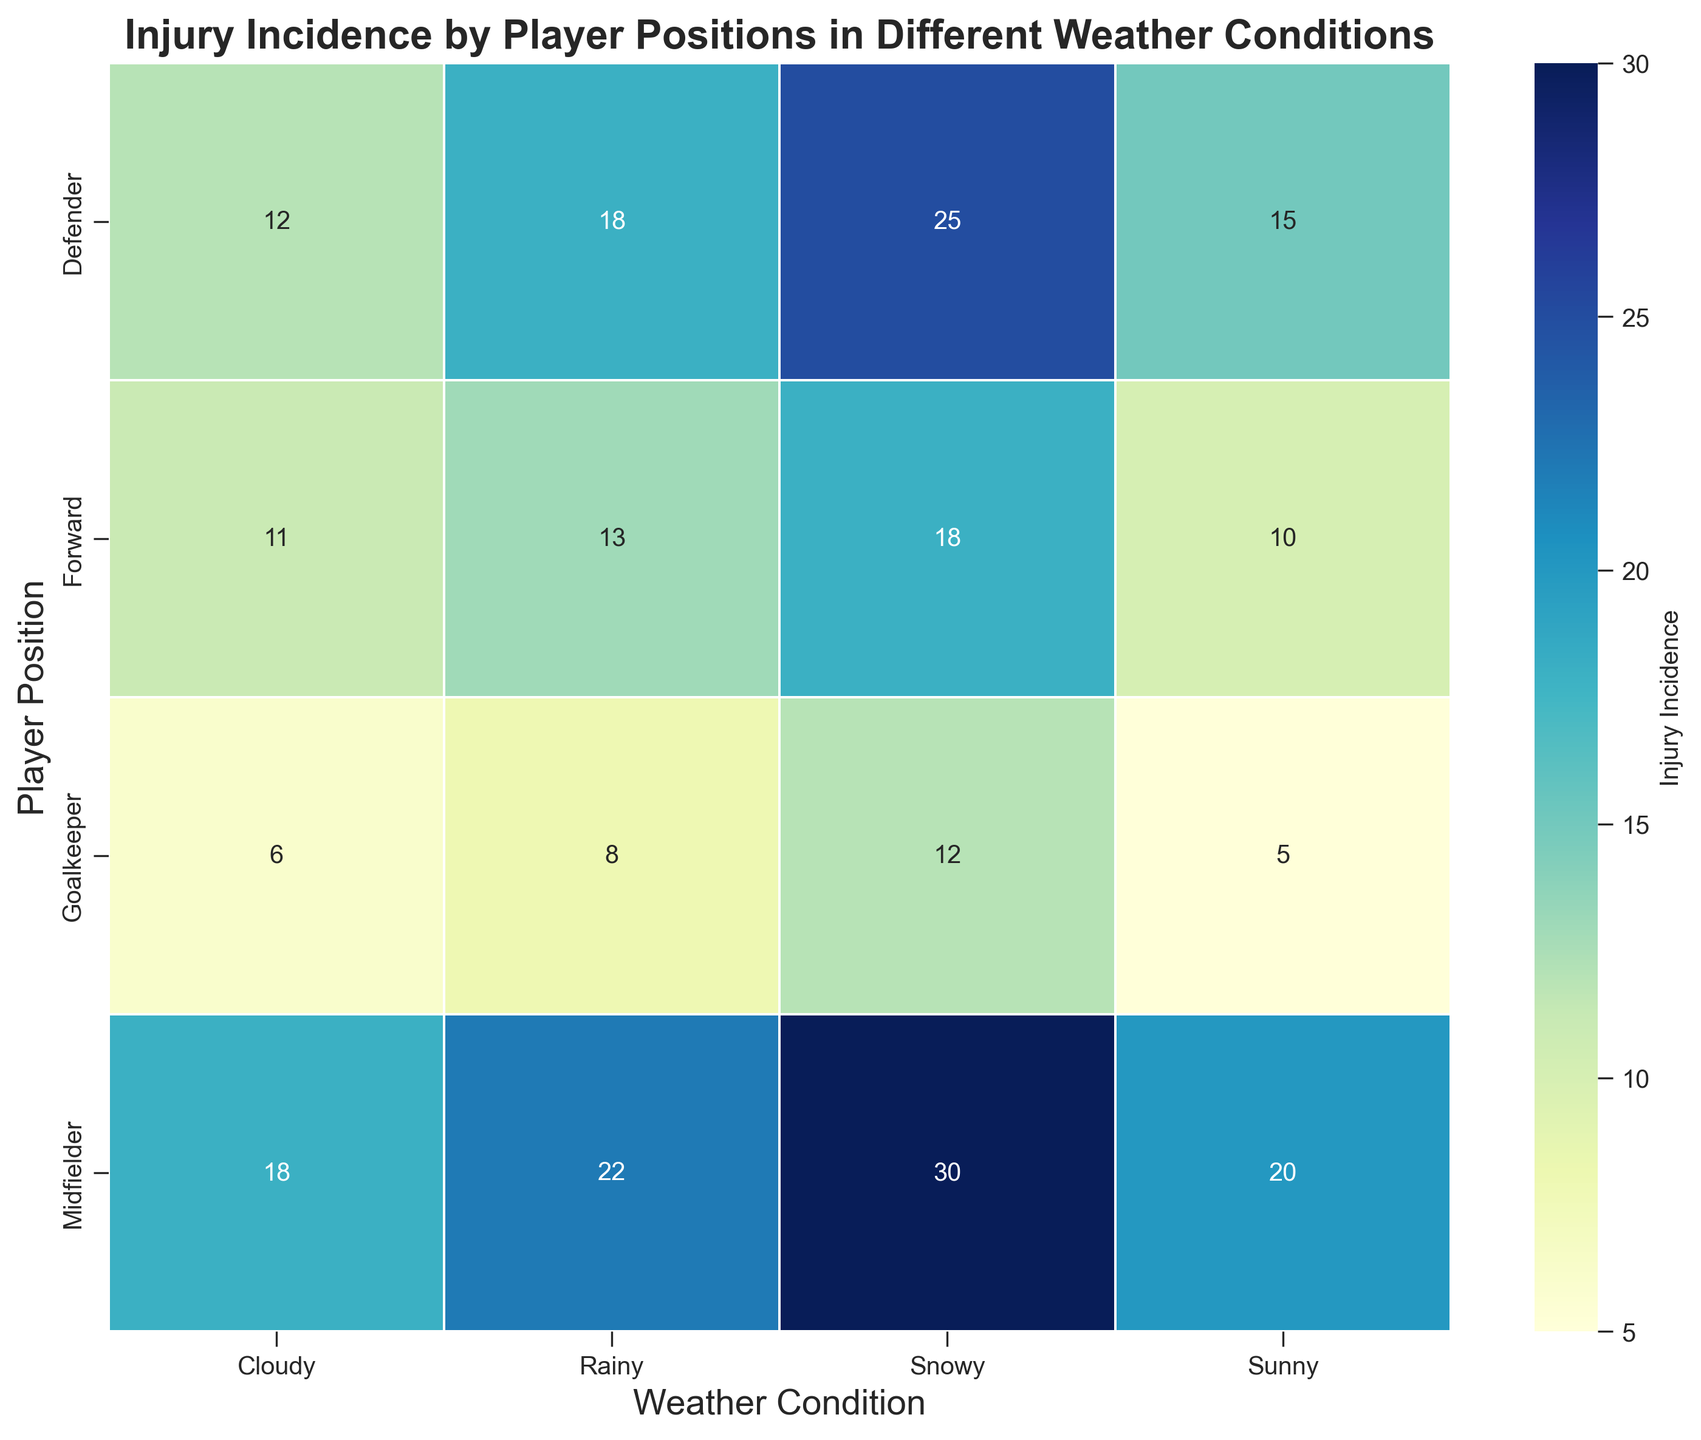What is the weather condition with the highest injury incidence for midfielders? Look at the row for Midfielder and find the cell with the highest number, which is 30 under Snowy.
Answer: Snowy Which player position has the lowest injury incidence in rainy weather? Check the Rainy column and find the smallest number, which is 8 corresponding to Goalkeepers.
Answer: Goalkeeper What is the total injury incidence for all player positions in sunny weather? Add up the Sunny values across all positions: 5 (Goalkeeper) + 15 (Defender) + 20 (Midfielder) + 10 (Forward) = 50.
Answer: 50 Is the injury incidence for defenders higher in snowy weather than in cloudy weather? Compare the values for Defender in Snowy (25) and Cloudy (12). Since 25 is greater than 12, the answer is yes.
Answer: Yes Which player position has the most variability in injury incidence across different weather conditions? Goalkeepers: 5, 8, 12, 6. Range = 12 - 5 = 7.
   Defenders: 15, 18, 25, 12. Range = 25 - 12 = 13.
   Midfielders: 20, 22, 30, 18. Range = 30 - 18 = 12.
   Forwards: 10, 13, 18, 11. Range = 18 - 10 = 8.
   Defenders have the most variability with a range of 13.
Answer: Defender By how much does the injury incidence increase for forwards when moving from sunny to snowy weather? Subtract the Sunny value for Forwards (10) from the Snowy value (18): 18 - 10 = 8.
Answer: 8 Which weather condition has the overall highest injury incidence when combining all positions? Add up values across all positions for each weather condition:
     Sunny: 5 + 15 + 20 + 10 = 50
     Rainy: 8 + 18 + 22 + 13 = 61
     Snowy: 12 + 25 + 30 + 18 = 85
     Cloudy: 6 + 12 + 18 + 11 = 47
     Snowy has the highest total with 85.
Answer: Snowy What is the difference in injury incidence between defenders and midfielders in snowy weather? Subtract the Snowy value for Defenders (25) from Midfielders (30): 30 - 25 = 5.
Answer: 5 Is there any player position for which the injury incidence is highest in cloudy weather? Look at the Cloudy column and find the maximum value in that column, which is 18 for Midfielders. But, it is not the highest across all other weather conditions for Midfielders whose highest value is 30 in Snowy weather. Therefore, no player position has the highest injury incidence in Cloudy.
Answer: No Compare the total injury incidences for Midfielders and Forwards across all weather conditions. Which position has a higher total? Sum the values for all weather conditions for both Midfielders and Forwards:
     Midfielders: 20 (Sunny) + 22 (Rainy) + 30 (Snowy) + 18 (Cloudy) = 90
     Forwards: 10 (Sunny) + 13 (Rainy) + 18 (Snowy) + 11 (Cloudy) = 52
     Midfielders have a higher total with 90 compared to 52 for Forwards.
Answer: Midfielder 